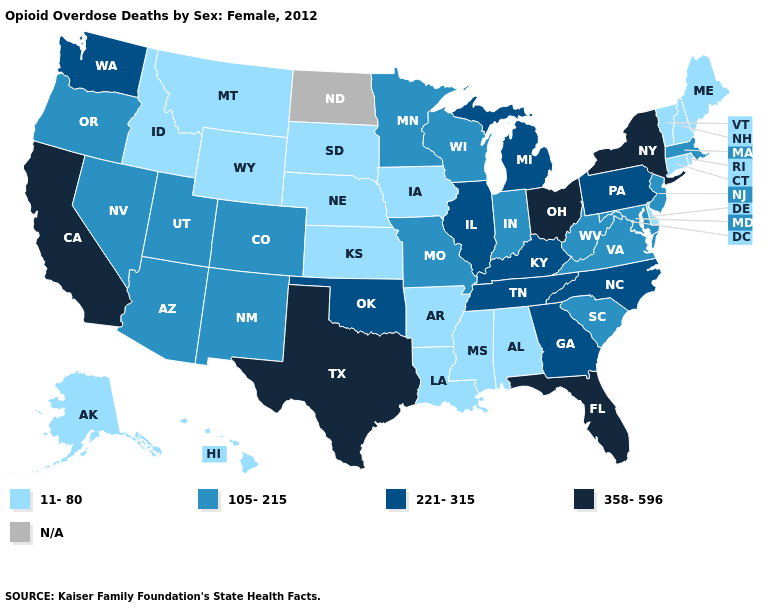Is the legend a continuous bar?
Give a very brief answer. No. Which states have the highest value in the USA?
Give a very brief answer. California, Florida, New York, Ohio, Texas. Name the states that have a value in the range 105-215?
Keep it brief. Arizona, Colorado, Indiana, Maryland, Massachusetts, Minnesota, Missouri, Nevada, New Jersey, New Mexico, Oregon, South Carolina, Utah, Virginia, West Virginia, Wisconsin. What is the lowest value in the USA?
Short answer required. 11-80. Name the states that have a value in the range N/A?
Give a very brief answer. North Dakota. Does Massachusetts have the highest value in the Northeast?
Give a very brief answer. No. Among the states that border West Virginia , which have the lowest value?
Be succinct. Maryland, Virginia. Among the states that border Oregon , which have the lowest value?
Answer briefly. Idaho. Does Arizona have the lowest value in the West?
Be succinct. No. Name the states that have a value in the range N/A?
Answer briefly. North Dakota. Does the first symbol in the legend represent the smallest category?
Be succinct. Yes. Name the states that have a value in the range N/A?
Answer briefly. North Dakota. Does Virginia have the highest value in the USA?
Short answer required. No. Among the states that border Oregon , does Idaho have the lowest value?
Give a very brief answer. Yes. 